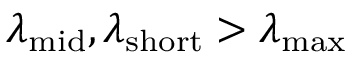Convert formula to latex. <formula><loc_0><loc_0><loc_500><loc_500>\lambda _ { m i d } , \lambda _ { s h o r t } > \lambda _ { \max }</formula> 